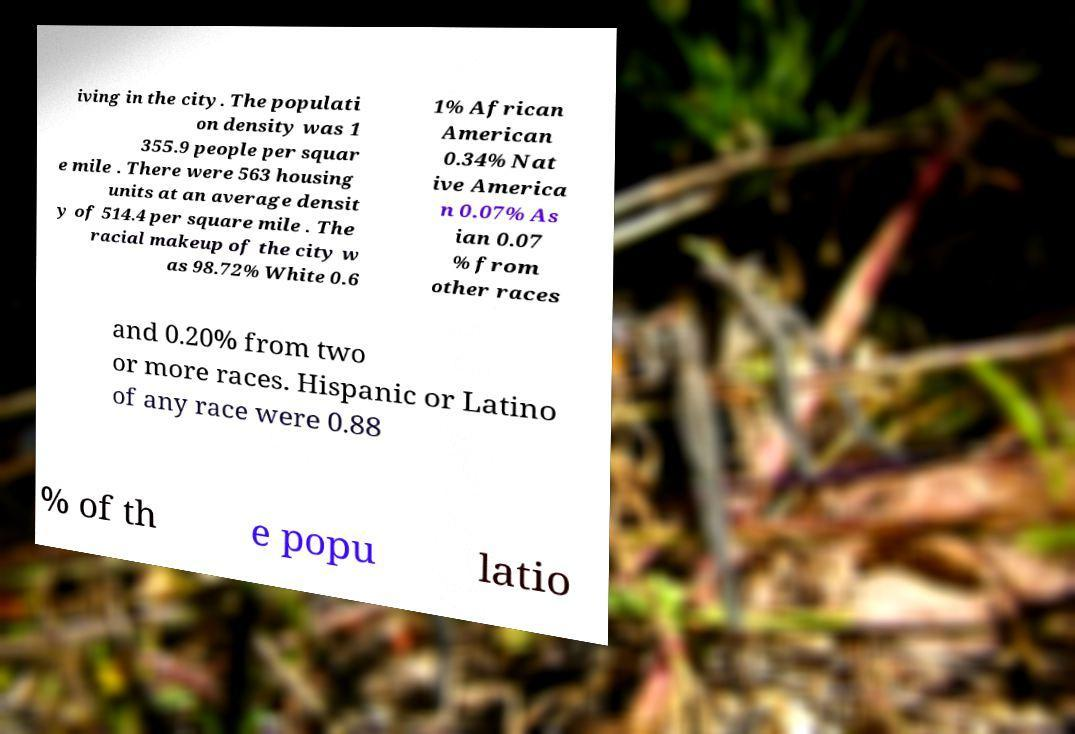Can you accurately transcribe the text from the provided image for me? iving in the city. The populati on density was 1 355.9 people per squar e mile . There were 563 housing units at an average densit y of 514.4 per square mile . The racial makeup of the city w as 98.72% White 0.6 1% African American 0.34% Nat ive America n 0.07% As ian 0.07 % from other races and 0.20% from two or more races. Hispanic or Latino of any race were 0.88 % of th e popu latio 